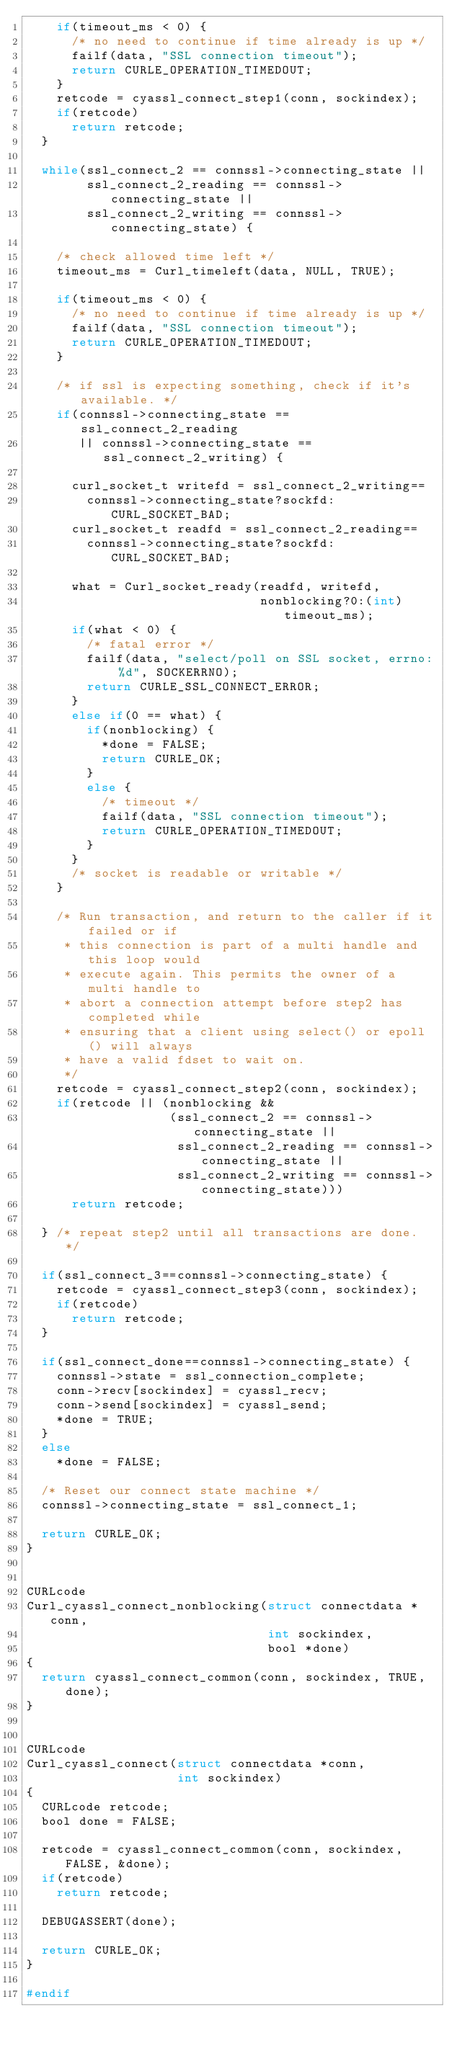<code> <loc_0><loc_0><loc_500><loc_500><_C_>    if(timeout_ms < 0) {
      /* no need to continue if time already is up */
      failf(data, "SSL connection timeout");
      return CURLE_OPERATION_TIMEDOUT;
    }
    retcode = cyassl_connect_step1(conn, sockindex);
    if(retcode)
      return retcode;
  }

  while(ssl_connect_2 == connssl->connecting_state ||
        ssl_connect_2_reading == connssl->connecting_state ||
        ssl_connect_2_writing == connssl->connecting_state) {

    /* check allowed time left */
    timeout_ms = Curl_timeleft(data, NULL, TRUE);

    if(timeout_ms < 0) {
      /* no need to continue if time already is up */
      failf(data, "SSL connection timeout");
      return CURLE_OPERATION_TIMEDOUT;
    }

    /* if ssl is expecting something, check if it's available. */
    if(connssl->connecting_state == ssl_connect_2_reading
       || connssl->connecting_state == ssl_connect_2_writing) {

      curl_socket_t writefd = ssl_connect_2_writing==
        connssl->connecting_state?sockfd:CURL_SOCKET_BAD;
      curl_socket_t readfd = ssl_connect_2_reading==
        connssl->connecting_state?sockfd:CURL_SOCKET_BAD;

      what = Curl_socket_ready(readfd, writefd,
                               nonblocking?0:(int)timeout_ms);
      if(what < 0) {
        /* fatal error */
        failf(data, "select/poll on SSL socket, errno: %d", SOCKERRNO);
        return CURLE_SSL_CONNECT_ERROR;
      }
      else if(0 == what) {
        if(nonblocking) {
          *done = FALSE;
          return CURLE_OK;
        }
        else {
          /* timeout */
          failf(data, "SSL connection timeout");
          return CURLE_OPERATION_TIMEDOUT;
        }
      }
      /* socket is readable or writable */
    }

    /* Run transaction, and return to the caller if it failed or if
     * this connection is part of a multi handle and this loop would
     * execute again. This permits the owner of a multi handle to
     * abort a connection attempt before step2 has completed while
     * ensuring that a client using select() or epoll() will always
     * have a valid fdset to wait on.
     */
    retcode = cyassl_connect_step2(conn, sockindex);
    if(retcode || (nonblocking &&
                   (ssl_connect_2 == connssl->connecting_state ||
                    ssl_connect_2_reading == connssl->connecting_state ||
                    ssl_connect_2_writing == connssl->connecting_state)))
      return retcode;

  } /* repeat step2 until all transactions are done. */

  if(ssl_connect_3==connssl->connecting_state) {
    retcode = cyassl_connect_step3(conn, sockindex);
    if(retcode)
      return retcode;
  }

  if(ssl_connect_done==connssl->connecting_state) {
    connssl->state = ssl_connection_complete;
    conn->recv[sockindex] = cyassl_recv;
    conn->send[sockindex] = cyassl_send;
    *done = TRUE;
  }
  else
    *done = FALSE;

  /* Reset our connect state machine */
  connssl->connecting_state = ssl_connect_1;

  return CURLE_OK;
}


CURLcode
Curl_cyassl_connect_nonblocking(struct connectdata *conn,
                                int sockindex,
                                bool *done)
{
  return cyassl_connect_common(conn, sockindex, TRUE, done);
}


CURLcode
Curl_cyassl_connect(struct connectdata *conn,
                    int sockindex)
{
  CURLcode retcode;
  bool done = FALSE;

  retcode = cyassl_connect_common(conn, sockindex, FALSE, &done);
  if(retcode)
    return retcode;

  DEBUGASSERT(done);

  return CURLE_OK;
}

#endif
</code> 